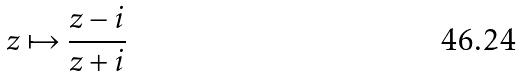<formula> <loc_0><loc_0><loc_500><loc_500>z \mapsto \frac { z - i } { z + i }</formula> 